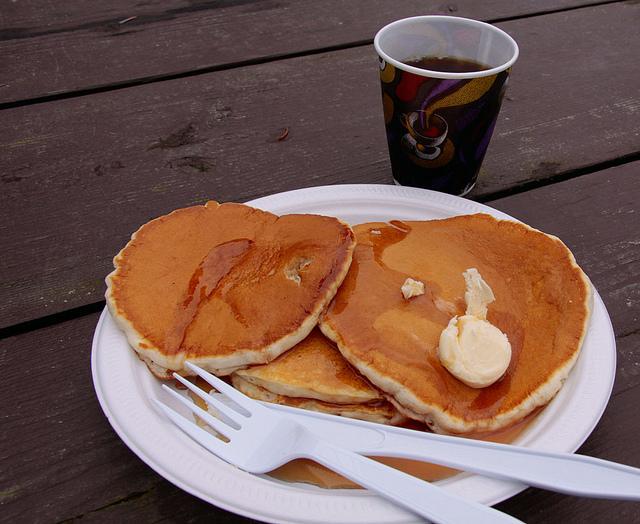Is there any silverware on the plate?
Concise answer only. Yes. What utensil is under the fork?
Be succinct. Knife. What color are the plastic utensils?
Concise answer only. White. What fruit is on the pancake?
Quick response, please. None. 